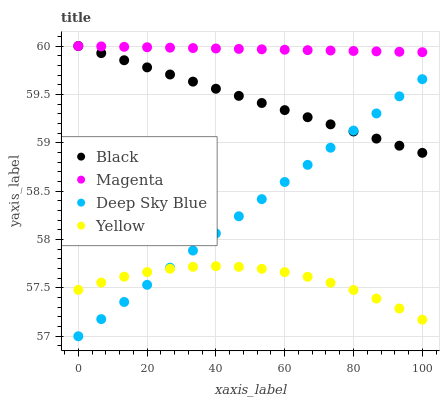Does Yellow have the minimum area under the curve?
Answer yes or no. Yes. Does Magenta have the maximum area under the curve?
Answer yes or no. Yes. Does Black have the minimum area under the curve?
Answer yes or no. No. Does Black have the maximum area under the curve?
Answer yes or no. No. Is Black the smoothest?
Answer yes or no. Yes. Is Yellow the roughest?
Answer yes or no. Yes. Is Yellow the smoothest?
Answer yes or no. No. Is Black the roughest?
Answer yes or no. No. Does Deep Sky Blue have the lowest value?
Answer yes or no. Yes. Does Black have the lowest value?
Answer yes or no. No. Does Black have the highest value?
Answer yes or no. Yes. Does Yellow have the highest value?
Answer yes or no. No. Is Yellow less than Black?
Answer yes or no. Yes. Is Magenta greater than Yellow?
Answer yes or no. Yes. Does Deep Sky Blue intersect Yellow?
Answer yes or no. Yes. Is Deep Sky Blue less than Yellow?
Answer yes or no. No. Is Deep Sky Blue greater than Yellow?
Answer yes or no. No. Does Yellow intersect Black?
Answer yes or no. No. 